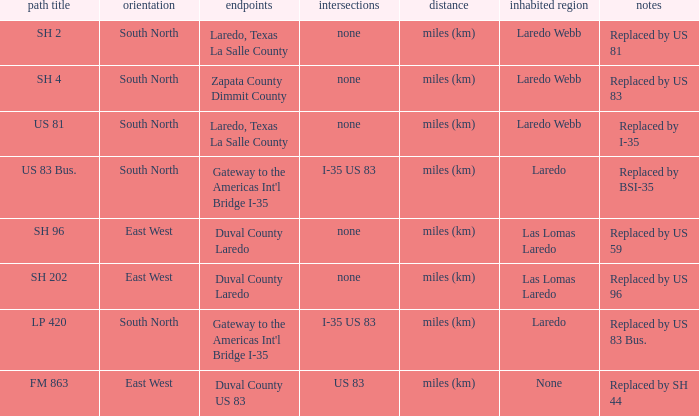How many junctions have "replaced by bsi-35" listed in their remarks section? 1.0. 